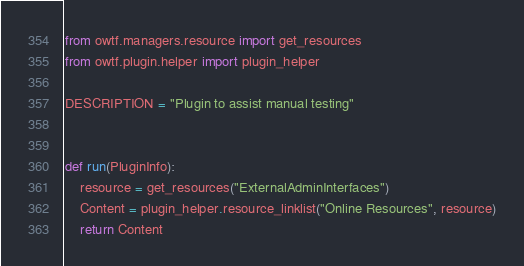Convert code to text. <code><loc_0><loc_0><loc_500><loc_500><_Python_>from owtf.managers.resource import get_resources
from owtf.plugin.helper import plugin_helper

DESCRIPTION = "Plugin to assist manual testing"


def run(PluginInfo):
    resource = get_resources("ExternalAdminInterfaces")
    Content = plugin_helper.resource_linklist("Online Resources", resource)
    return Content
</code> 